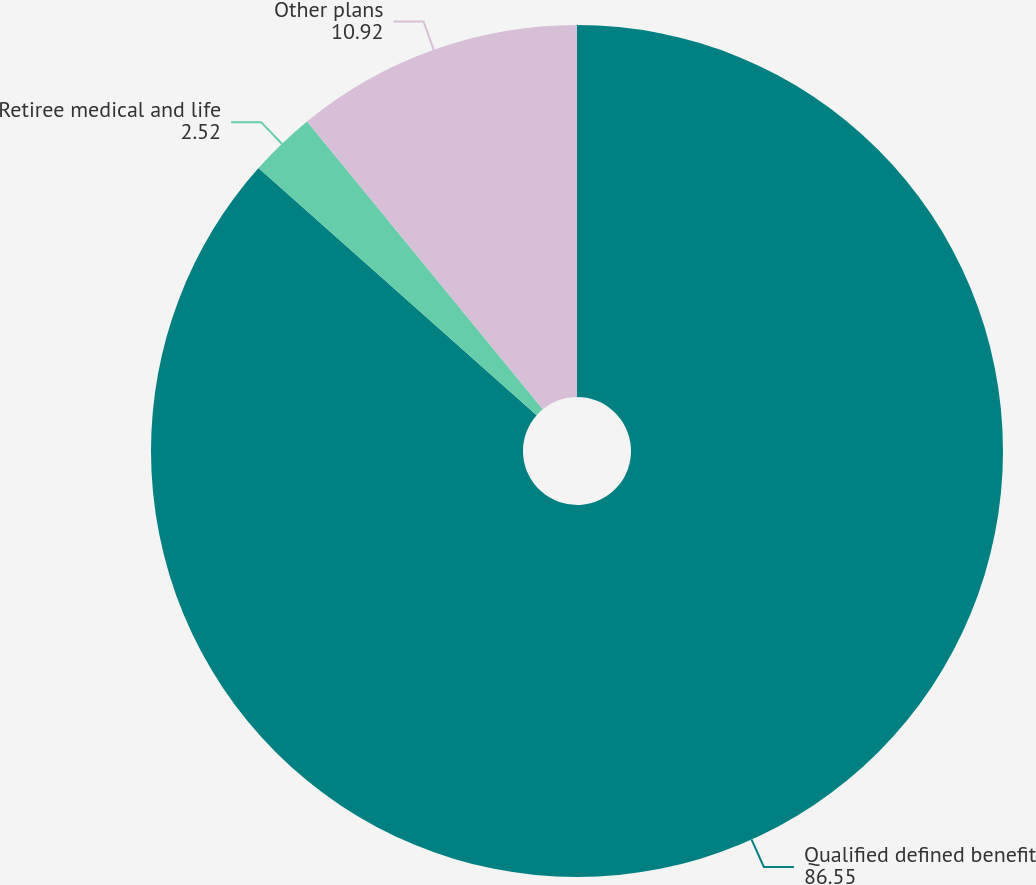Convert chart to OTSL. <chart><loc_0><loc_0><loc_500><loc_500><pie_chart><fcel>Qualified defined benefit<fcel>Retiree medical and life<fcel>Other plans<nl><fcel>86.55%<fcel>2.52%<fcel>10.92%<nl></chart> 